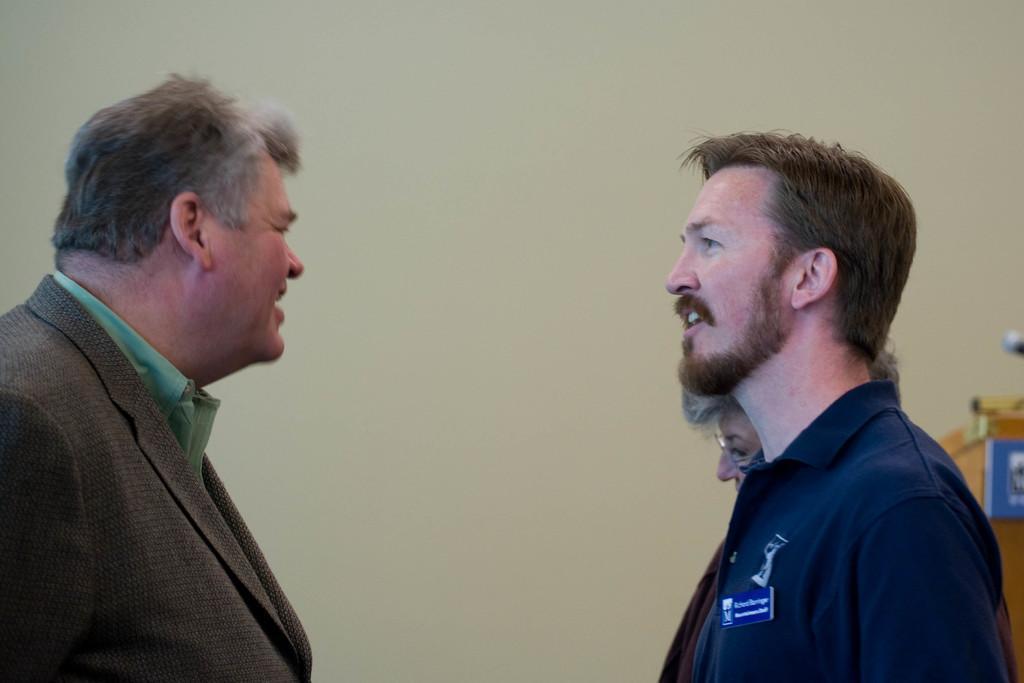Please provide a concise description of this image. In this image we can see there are three persons standing. At the right side, it looks like a podium. In the background, we can see the wall. 